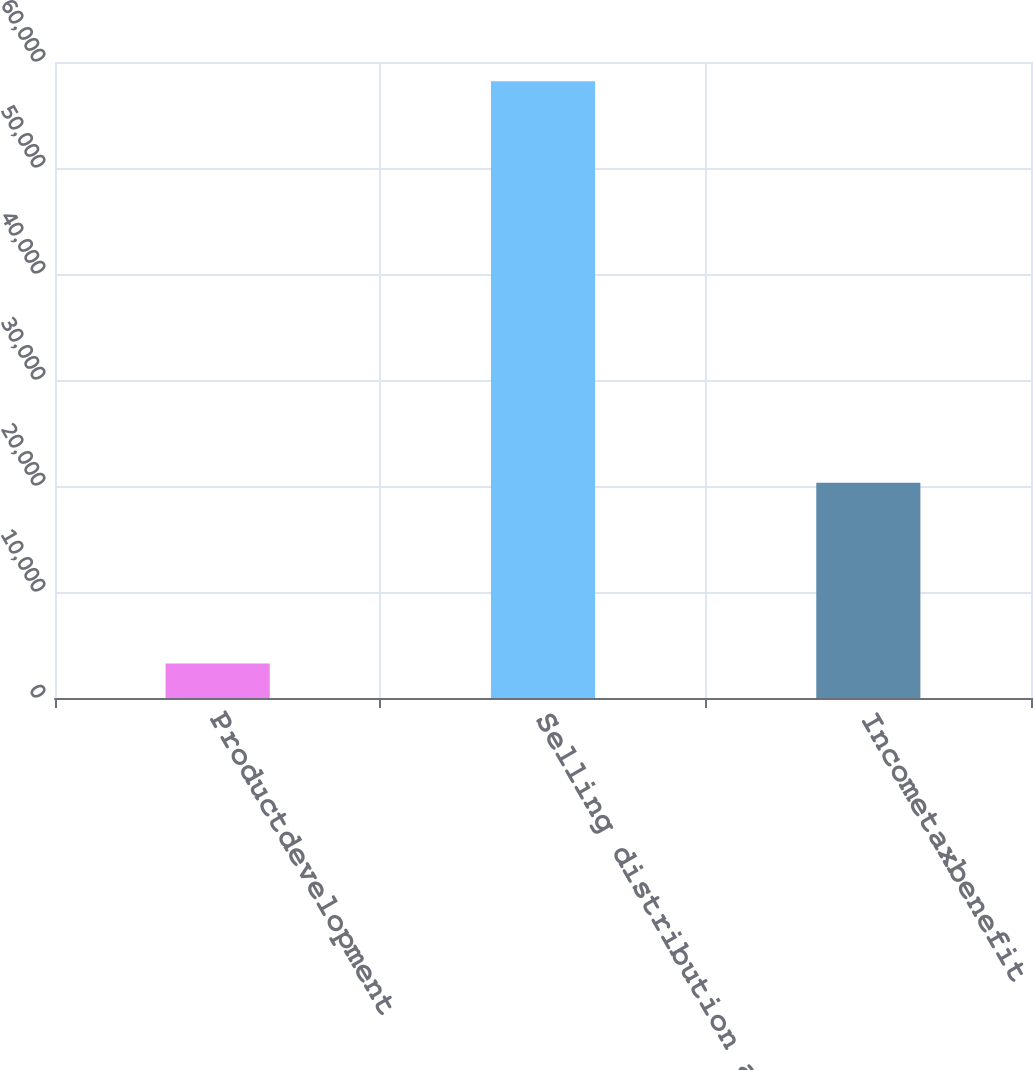Convert chart to OTSL. <chart><loc_0><loc_0><loc_500><loc_500><bar_chart><fcel>Productdevelopment<fcel>Selling distribution and<fcel>Incometaxbenefit<nl><fcel>3248<fcel>58176<fcel>20298<nl></chart> 